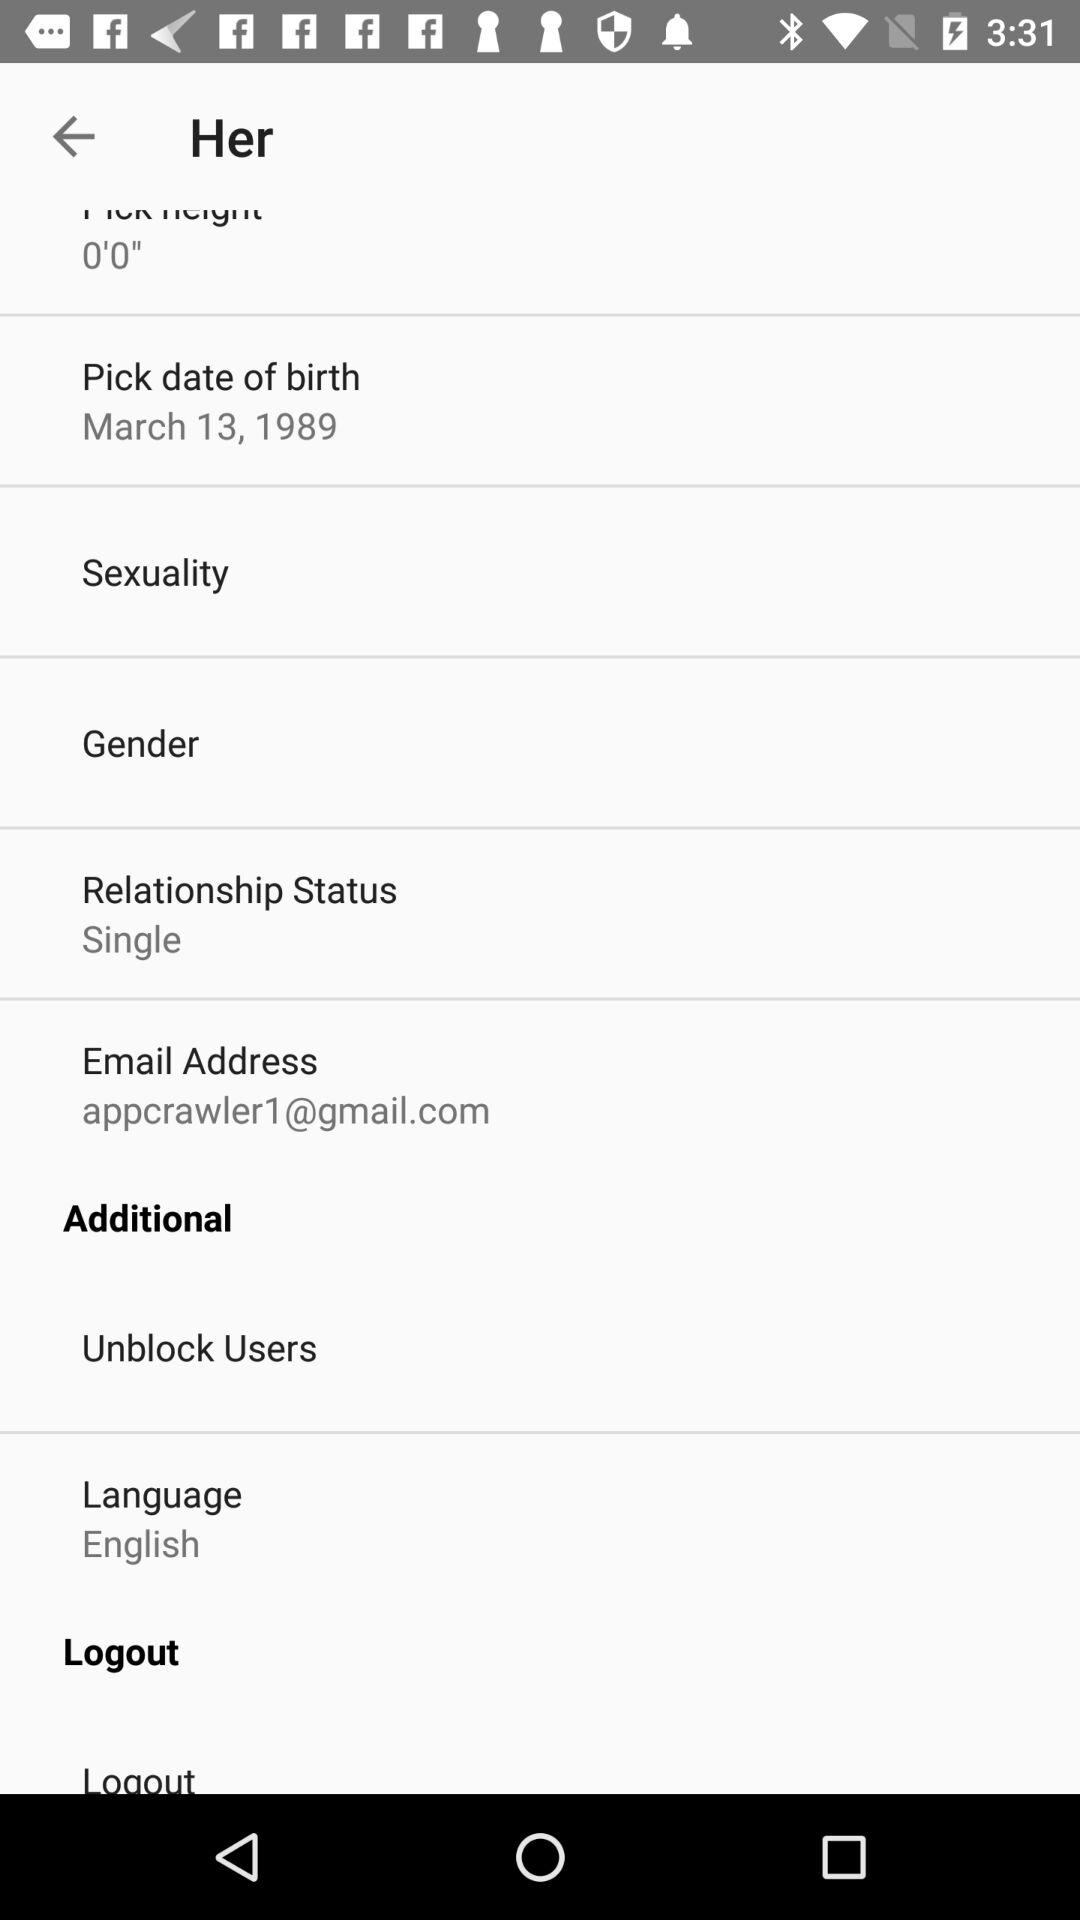What is the relationship status?
Answer the question using a single word or phrase. The relationship status is "Single" 